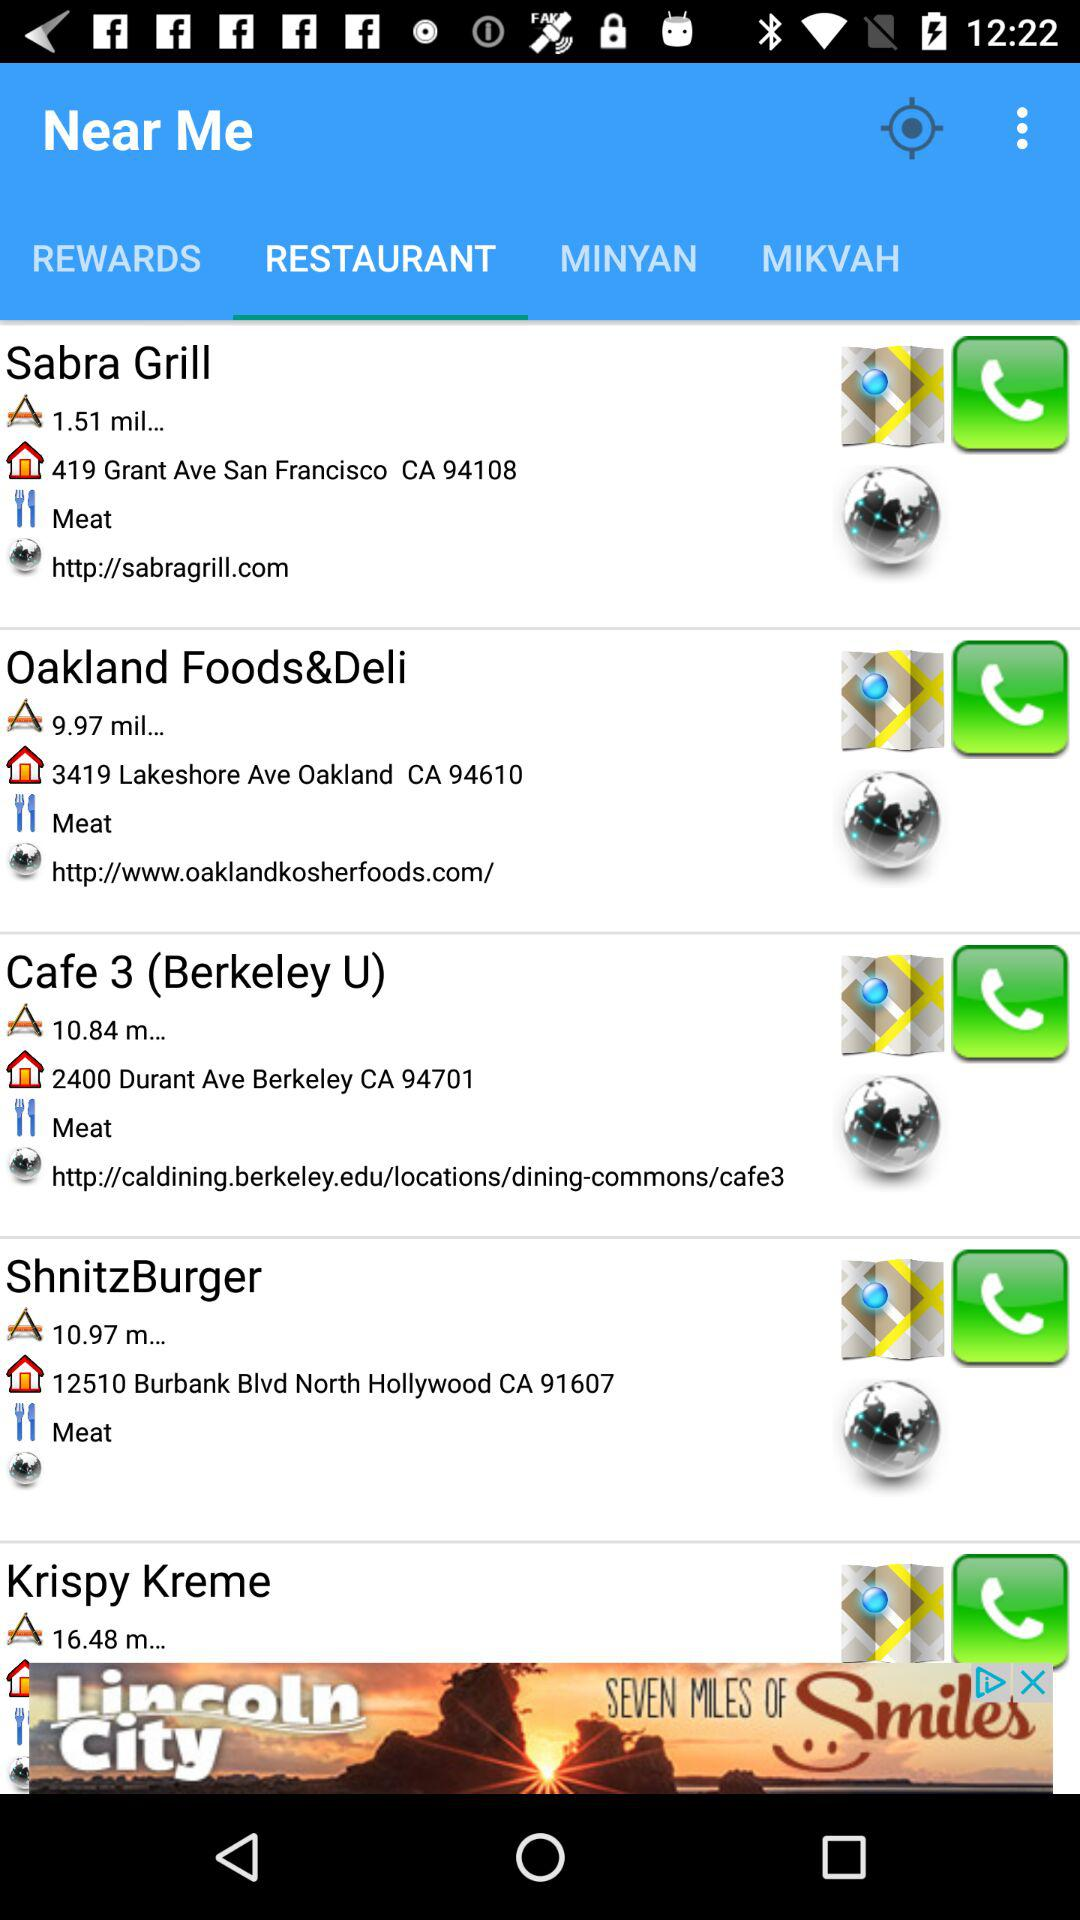What is the website for Sabra Grill? The website is "http://sabragrill.com". 